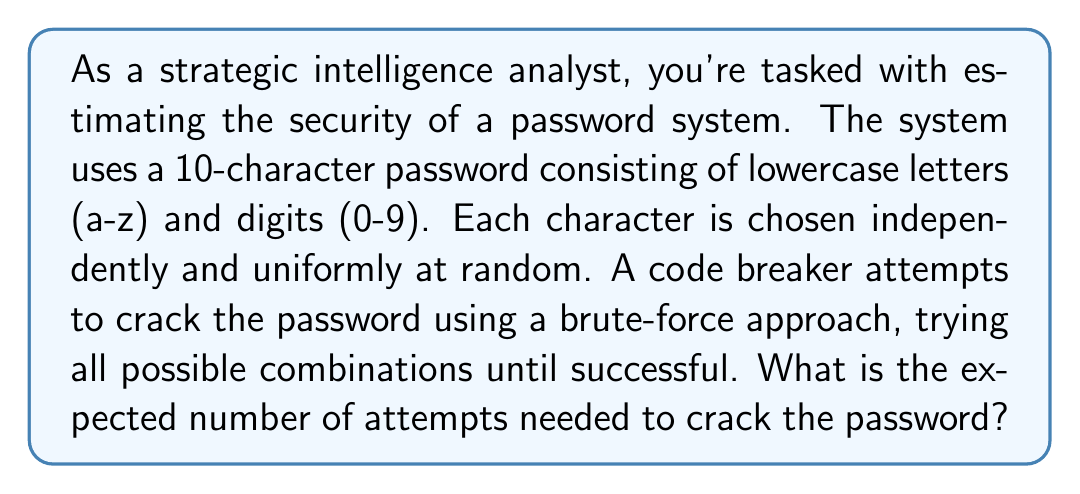Provide a solution to this math problem. Let's approach this step-by-step:

1) First, we need to calculate the total number of possible passwords:
   - There are 26 lowercase letters and 10 digits, so 36 choices for each character.
   - The password is 10 characters long.
   - Total number of possible passwords = $36^{10}$

2) The probability of guessing the correct password on any given attempt is:
   $p = \frac{1}{36^{10}}$

3) This scenario follows a geometric distribution. The expected number of trials until success for a geometric distribution is given by:
   $E(X) = \frac{1}{p}$

4) Substituting our probability:
   $E(X) = \frac{1}{\frac{1}{36^{10}}} = 36^{10}$

5) To get a sense of the magnitude:
   $36^{10} = 3,656,158,440,062,976 \approx 3.66 \times 10^{15}$

This means that, on average, the code breaker would need to make about $3.66 \times 10^{15}$ attempts before successfully cracking the password.
Answer: The expected number of attempts needed to crack the password is $36^{10} \approx 3.66 \times 10^{15}$. 